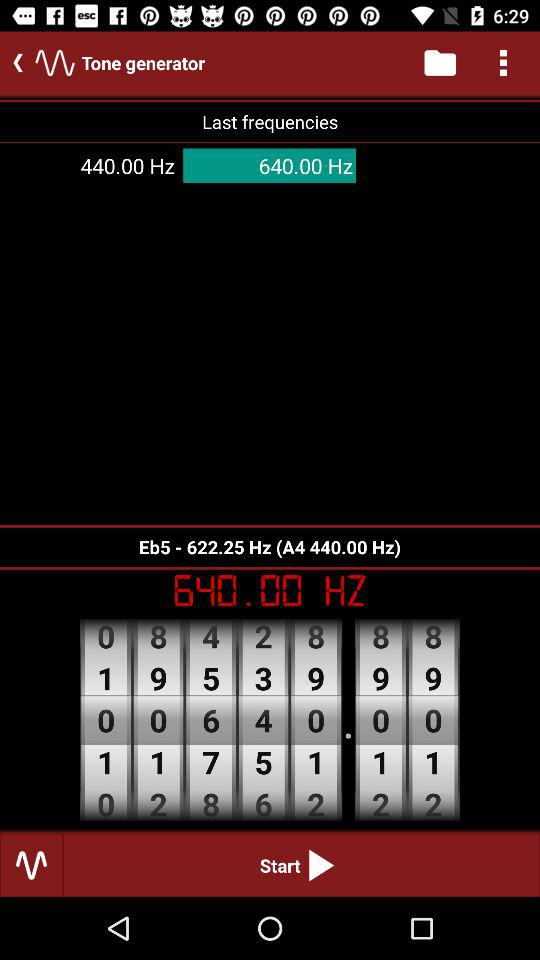What is the selected frequency? The selected frequency is 640.00 Hz. 